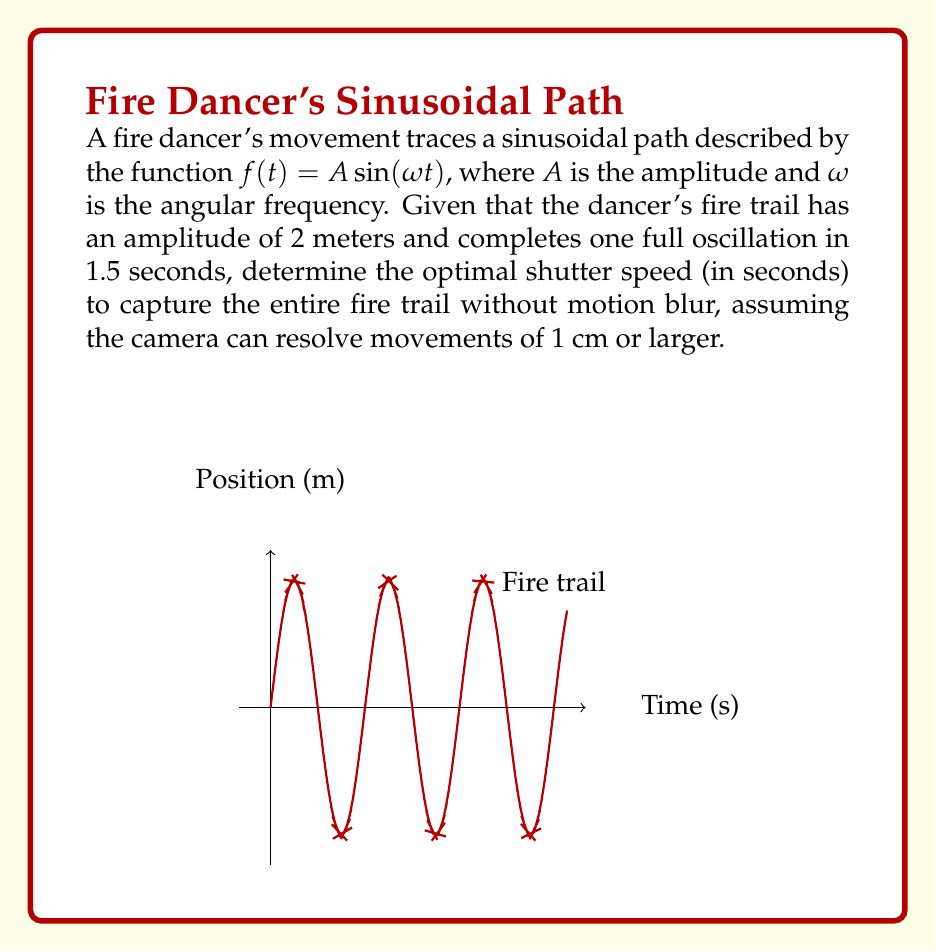Can you answer this question? Let's approach this step-by-step:

1) First, we need to find the angular frequency $\omega$:
   $$\omega = \frac{2\pi}{T}$$
   where $T$ is the period (1.5 seconds).
   $$\omega = \frac{2\pi}{1.5} = \frac{4\pi}{3} \approx 4.19 \text{ rad/s}$$

2) The velocity of the fire trail is given by the derivative of the position function:
   $$v(t) = f'(t) = A\omega \cos(\omega t)$$

3) The maximum velocity occurs when $\cos(\omega t) = 1$:
   $$v_{max} = A\omega = 2 \cdot \frac{4\pi}{3} = \frac{8\pi}{3} \approx 8.38 \text{ m/s}$$

4) To avoid motion blur, the fire trail should not move more than 1 cm during the exposure. We can calculate the time $t$ for a 1 cm movement:
   $$0.01 = v_{max} \cdot t$$
   $$t = \frac{0.01}{v_{max}} = \frac{0.01}{\frac{8\pi}{3}} = \frac{3}{800\pi} \approx 0.00119 \text{ seconds}$$

5) Therefore, the optimal shutter speed should be no slower than approximately 0.00119 seconds or 1/840 of a second.

6) In photography, standard shutter speeds are typically expressed as powers of 2. The closest standard shutter speed that's faster than our calculated value is 1/1000 second.
Answer: 1/1000 second 